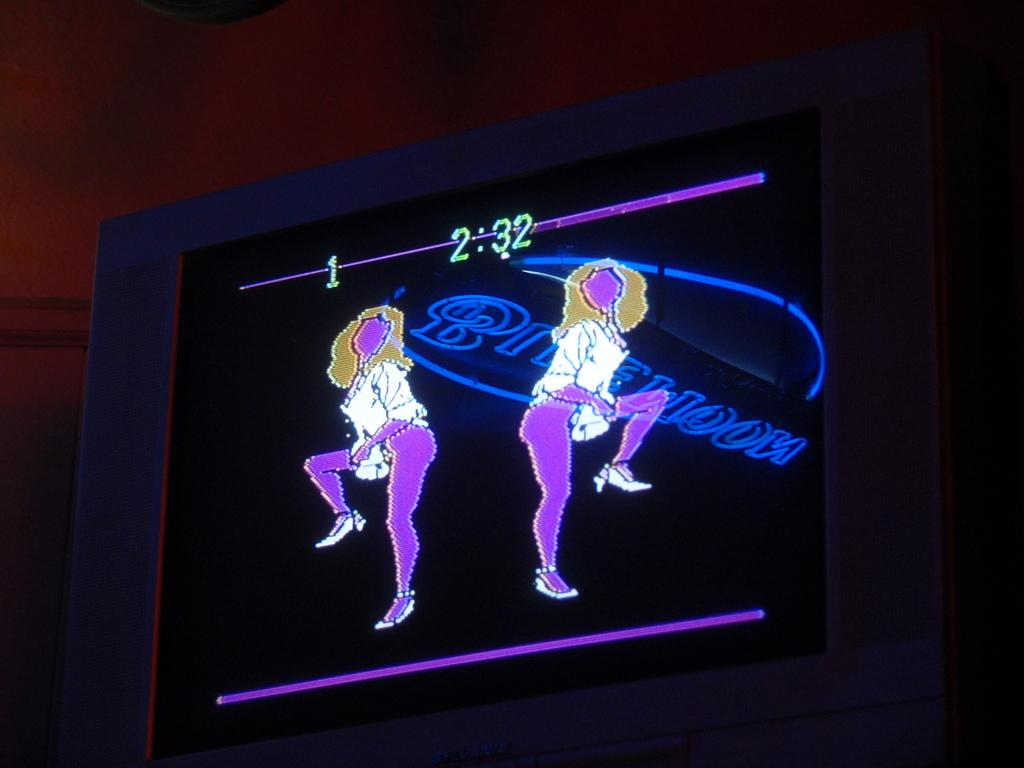What is the main feature of the image? There is a black color screen in the image. What is happening on the screen? There are two animated images of women dancing on the screen. What type of text is present on the screen? There is a blue color text on the screen. How would you describe the overall color scheme of the image? The background of the image is dark in color. Can you see any flights taking off in the image? There are no flights or any reference to air travel in the image. Are there any trousers visible on the dancing women in the image? The image only shows animated dancing women, and no specific clothing details are visible. 